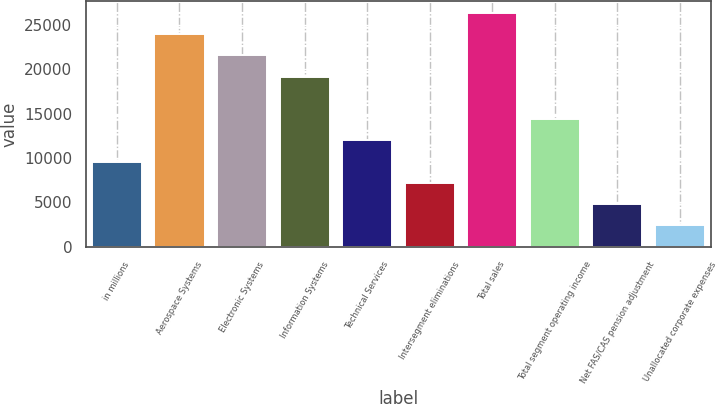<chart> <loc_0><loc_0><loc_500><loc_500><bar_chart><fcel>in millions<fcel>Aerospace Systems<fcel>Electronic Systems<fcel>Information Systems<fcel>Technical Services<fcel>Intersegment eliminations<fcel>Total sales<fcel>Total segment operating income<fcel>Net FAS/CAS pension adjustment<fcel>Unallocated corporate expenses<nl><fcel>9593.4<fcel>23979<fcel>21581.4<fcel>19183.8<fcel>11991<fcel>7195.8<fcel>26376.6<fcel>14388.6<fcel>4798.2<fcel>2400.6<nl></chart> 